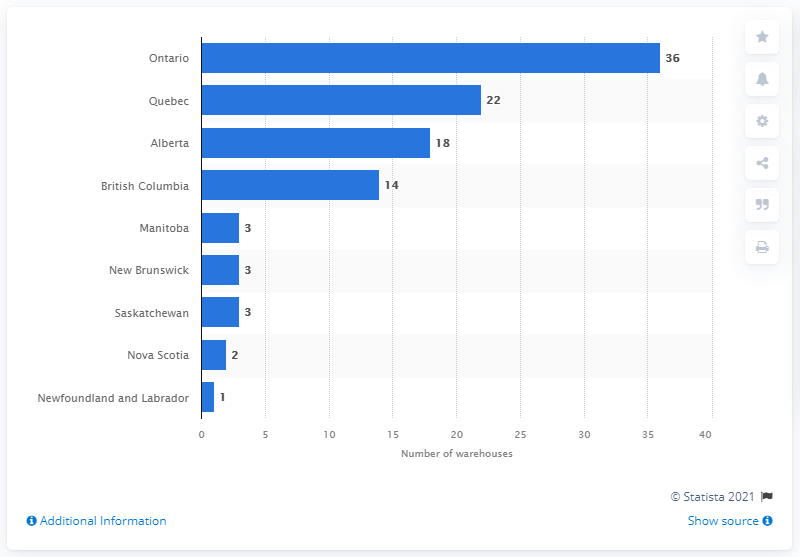Highlight a few significant elements in this photo. As of December 2020, there were 36 Costco warehouses located in the province of Ontario. The only Costco warehouse was located in Newfoundland and Labrador. 